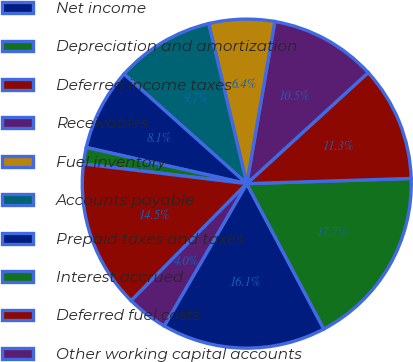Convert chart to OTSL. <chart><loc_0><loc_0><loc_500><loc_500><pie_chart><fcel>Net income<fcel>Depreciation and amortization<fcel>Deferred income taxes<fcel>Receivables<fcel>Fuel inventory<fcel>Accounts payable<fcel>Prepaid taxes and taxes<fcel>Interest accrued<fcel>Deferred fuel costs<fcel>Other working capital accounts<nl><fcel>16.13%<fcel>17.74%<fcel>11.29%<fcel>10.48%<fcel>6.45%<fcel>9.68%<fcel>8.07%<fcel>1.62%<fcel>14.51%<fcel>4.03%<nl></chart> 